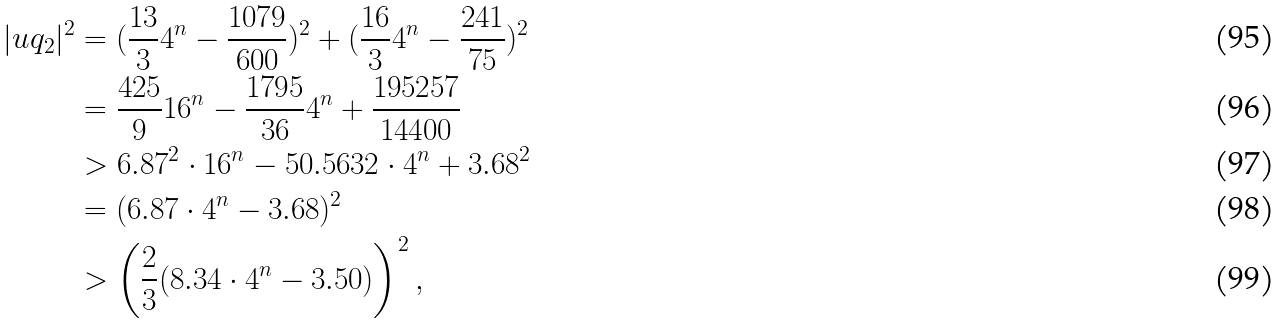Convert formula to latex. <formula><loc_0><loc_0><loc_500><loc_500>| u q _ { 2 } | ^ { 2 } & = ( \frac { 1 3 } { 3 } 4 ^ { n } - \frac { 1 0 7 9 } { 6 0 0 } ) ^ { 2 } + ( \frac { 1 6 } { 3 } 4 ^ { n } - \frac { 2 4 1 } { 7 5 } ) ^ { 2 } \\ & = \frac { 4 2 5 } { 9 } 1 6 ^ { n } - \frac { 1 7 9 5 } { 3 6 } 4 ^ { n } + \frac { 1 9 5 2 5 7 } { 1 4 4 0 0 } \\ & > 6 . 8 7 ^ { 2 } \cdot 1 6 ^ { n } - 5 0 . 5 6 3 2 \cdot 4 ^ { n } + 3 . 6 8 ^ { 2 } \\ & = ( 6 . 8 7 \cdot 4 ^ { n } - 3 . 6 8 ) ^ { 2 } \\ & > \left ( \frac { 2 } { 3 } ( 8 . 3 4 \cdot 4 ^ { n } - 3 . 5 0 ) \right ) ^ { 2 } ,</formula> 